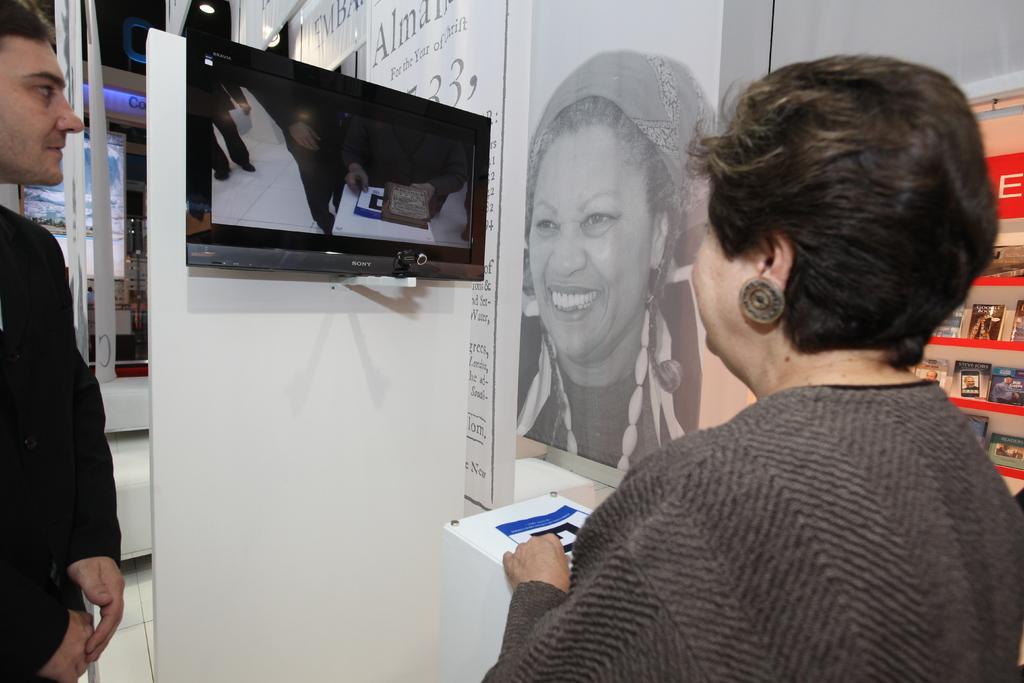Can you describe this image briefly? In the foreground of this image, on the right, there is a woman standing and a image of a woman on the wall. On the left, there is a man standing. In the middle, there is a screen to the wall and also on the right, there are few objects. In the background, there are few poles, a board and the lights. 